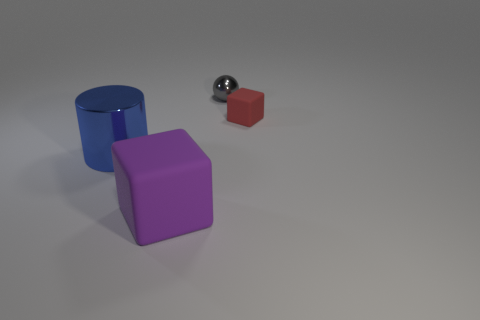Add 2 purple shiny spheres. How many objects exist? 6 Subtract all balls. How many objects are left? 3 Subtract all small cyan balls. Subtract all rubber cubes. How many objects are left? 2 Add 3 balls. How many balls are left? 4 Add 1 large cyan metallic spheres. How many large cyan metallic spheres exist? 1 Subtract 0 red cylinders. How many objects are left? 4 